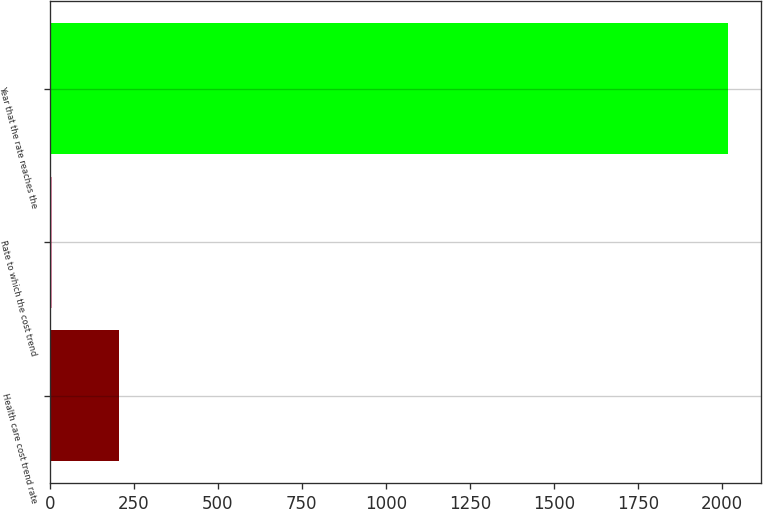Convert chart. <chart><loc_0><loc_0><loc_500><loc_500><bar_chart><fcel>Health care cost trend rate<fcel>Rate to which the cost trend<fcel>Year that the rate reaches the<nl><fcel>206.55<fcel>5.5<fcel>2016<nl></chart> 